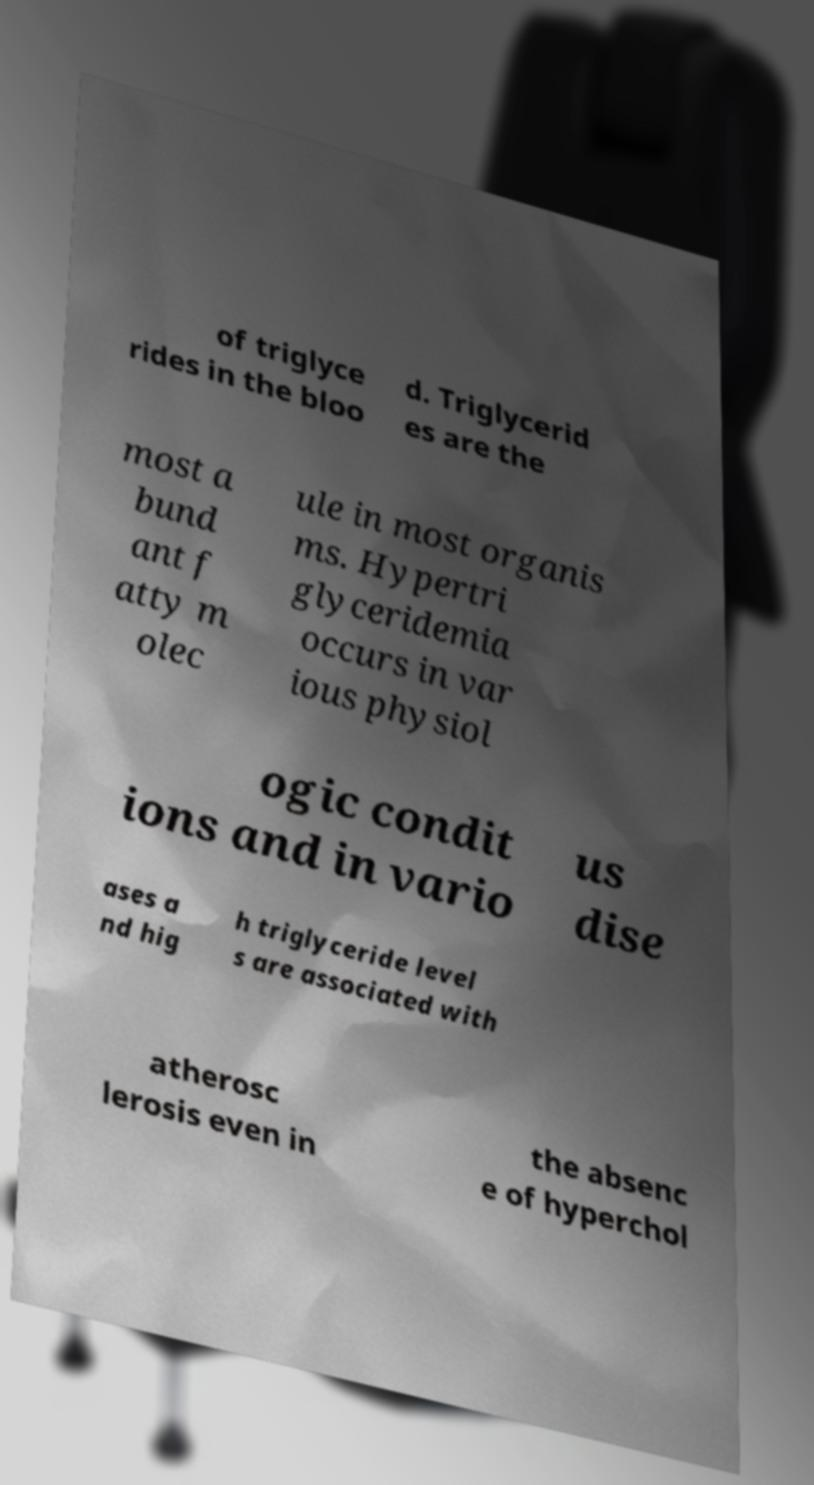Can you accurately transcribe the text from the provided image for me? of triglyce rides in the bloo d. Triglycerid es are the most a bund ant f atty m olec ule in most organis ms. Hypertri glyceridemia occurs in var ious physiol ogic condit ions and in vario us dise ases a nd hig h triglyceride level s are associated with atherosc lerosis even in the absenc e of hyperchol 